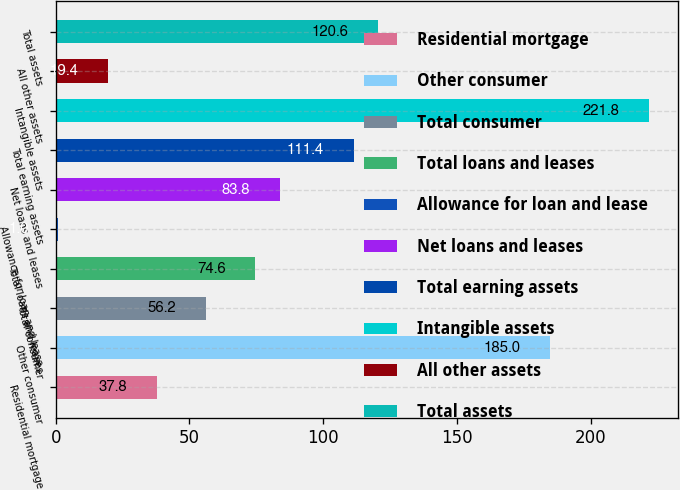Convert chart to OTSL. <chart><loc_0><loc_0><loc_500><loc_500><bar_chart><fcel>Residential mortgage<fcel>Other consumer<fcel>Total consumer<fcel>Total loans and leases<fcel>Allowance for loan and lease<fcel>Net loans and leases<fcel>Total earning assets<fcel>Intangible assets<fcel>All other assets<fcel>Total assets<nl><fcel>37.8<fcel>185<fcel>56.2<fcel>74.6<fcel>1<fcel>83.8<fcel>111.4<fcel>221.8<fcel>19.4<fcel>120.6<nl></chart> 